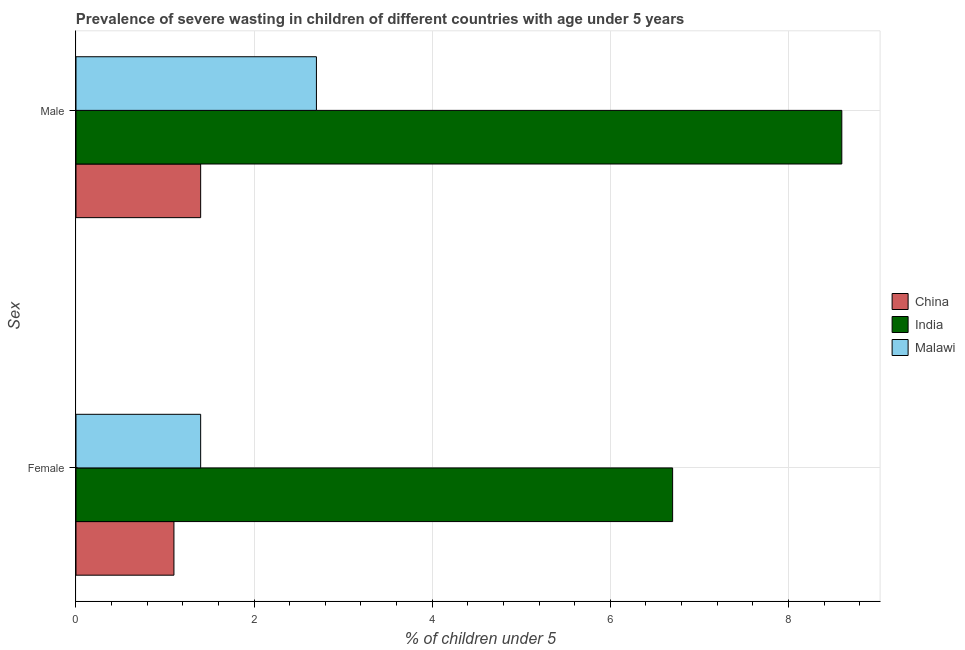Are the number of bars on each tick of the Y-axis equal?
Your answer should be very brief. Yes. What is the label of the 1st group of bars from the top?
Offer a terse response. Male. What is the percentage of undernourished male children in China?
Your response must be concise. 1.4. Across all countries, what is the maximum percentage of undernourished male children?
Provide a succinct answer. 8.6. Across all countries, what is the minimum percentage of undernourished male children?
Ensure brevity in your answer.  1.4. What is the total percentage of undernourished male children in the graph?
Offer a very short reply. 12.7. What is the difference between the percentage of undernourished female children in China and that in India?
Your answer should be compact. -5.6. What is the difference between the percentage of undernourished male children in Malawi and the percentage of undernourished female children in China?
Keep it short and to the point. 1.6. What is the average percentage of undernourished male children per country?
Offer a very short reply. 4.23. What is the difference between the percentage of undernourished female children and percentage of undernourished male children in China?
Offer a terse response. -0.3. What is the ratio of the percentage of undernourished female children in Malawi to that in China?
Your response must be concise. 1.27. What does the 3rd bar from the top in Female represents?
Your response must be concise. China. What does the 2nd bar from the bottom in Male represents?
Your response must be concise. India. Are all the bars in the graph horizontal?
Provide a succinct answer. Yes. What is the difference between two consecutive major ticks on the X-axis?
Offer a very short reply. 2. Are the values on the major ticks of X-axis written in scientific E-notation?
Keep it short and to the point. No. How many legend labels are there?
Provide a short and direct response. 3. How are the legend labels stacked?
Your response must be concise. Vertical. What is the title of the graph?
Offer a very short reply. Prevalence of severe wasting in children of different countries with age under 5 years. What is the label or title of the X-axis?
Provide a short and direct response.  % of children under 5. What is the label or title of the Y-axis?
Make the answer very short. Sex. What is the  % of children under 5 in China in Female?
Ensure brevity in your answer.  1.1. What is the  % of children under 5 in India in Female?
Ensure brevity in your answer.  6.7. What is the  % of children under 5 in Malawi in Female?
Give a very brief answer. 1.4. What is the  % of children under 5 of China in Male?
Give a very brief answer. 1.4. What is the  % of children under 5 of India in Male?
Your answer should be compact. 8.6. What is the  % of children under 5 of Malawi in Male?
Keep it short and to the point. 2.7. Across all Sex, what is the maximum  % of children under 5 in China?
Offer a terse response. 1.4. Across all Sex, what is the maximum  % of children under 5 in India?
Keep it short and to the point. 8.6. Across all Sex, what is the maximum  % of children under 5 of Malawi?
Make the answer very short. 2.7. Across all Sex, what is the minimum  % of children under 5 of China?
Your response must be concise. 1.1. Across all Sex, what is the minimum  % of children under 5 of India?
Provide a short and direct response. 6.7. Across all Sex, what is the minimum  % of children under 5 in Malawi?
Your answer should be very brief. 1.4. What is the total  % of children under 5 in China in the graph?
Provide a succinct answer. 2.5. What is the total  % of children under 5 in India in the graph?
Your answer should be compact. 15.3. What is the difference between the  % of children under 5 in India in Female and that in Male?
Ensure brevity in your answer.  -1.9. What is the difference between the  % of children under 5 in Malawi in Female and that in Male?
Your response must be concise. -1.3. What is the difference between the  % of children under 5 of China in Female and the  % of children under 5 of Malawi in Male?
Offer a terse response. -1.6. What is the average  % of children under 5 in India per Sex?
Keep it short and to the point. 7.65. What is the average  % of children under 5 of Malawi per Sex?
Give a very brief answer. 2.05. What is the difference between the  % of children under 5 of China and  % of children under 5 of Malawi in Female?
Your answer should be compact. -0.3. What is the difference between the  % of children under 5 of India and  % of children under 5 of Malawi in Male?
Provide a succinct answer. 5.9. What is the ratio of the  % of children under 5 in China in Female to that in Male?
Your response must be concise. 0.79. What is the ratio of the  % of children under 5 of India in Female to that in Male?
Your answer should be compact. 0.78. What is the ratio of the  % of children under 5 of Malawi in Female to that in Male?
Provide a short and direct response. 0.52. What is the difference between the highest and the lowest  % of children under 5 in India?
Make the answer very short. 1.9. What is the difference between the highest and the lowest  % of children under 5 of Malawi?
Make the answer very short. 1.3. 